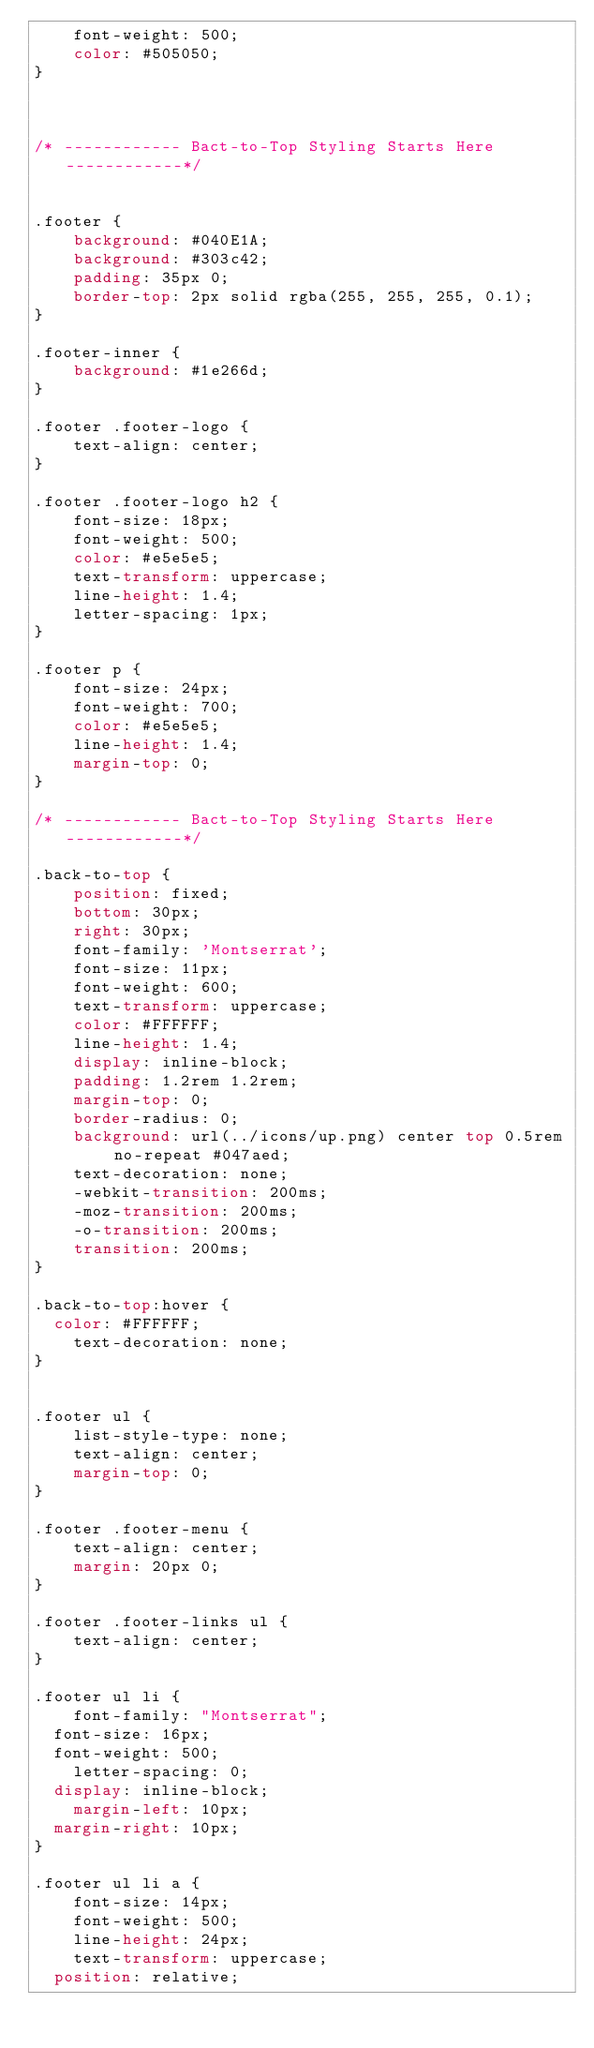<code> <loc_0><loc_0><loc_500><loc_500><_CSS_>	font-weight: 500;
	color: #505050;
}



/* ------------ Bact-to-Top Styling Starts Here ------------*/


.footer {
	background: #040E1A;
	background: #303c42;
	padding: 35px 0;
	border-top: 2px solid rgba(255, 255, 255, 0.1);
}

.footer-inner {
	background: #1e266d;
}

.footer .footer-logo {
	text-align: center;
}

.footer .footer-logo h2 {
	font-size: 18px;
	font-weight: 500;
	color: #e5e5e5;
	text-transform: uppercase;
	line-height: 1.4;
	letter-spacing: 1px;
}

.footer p {
	font-size: 24px;
	font-weight: 700;
	color: #e5e5e5;
	line-height: 1.4;
	margin-top: 0;
}

/* ------------ Bact-to-Top Styling Starts Here ------------*/

.back-to-top {
	position: fixed;
	bottom: 30px;
	right: 30px;
	font-family: 'Montserrat';
	font-size: 11px;
	font-weight: 600;
	text-transform: uppercase;
	color: #FFFFFF;
	line-height: 1.4;
	display: inline-block;
	padding: 1.2rem 1.2rem;
	margin-top: 0;
	border-radius: 0;
	background: url(../icons/up.png) center top 0.5rem no-repeat #047aed;
	text-decoration: none;
	-webkit-transition: 200ms;
	-moz-transition: 200ms;
	-o-transition: 200ms;
	transition: 200ms;
}

.back-to-top:hover {
  color: #FFFFFF;
	text-decoration: none;
}


.footer ul {
	list-style-type: none;
	text-align: center;
	margin-top: 0;
}

.footer .footer-menu {
	text-align: center;
	margin: 20px 0;
}

.footer .footer-links ul {
	text-align: center;
}

.footer ul li {
	font-family: "Montserrat";
  font-size: 16px;
  font-weight: 500;
	letter-spacing: 0;
  display: inline-block;
	margin-left: 10px;
  margin-right: 10px;
}

.footer ul li a {
	font-size: 14px;
	font-weight: 500;
	line-height: 24px;
	text-transform: uppercase;
  position: relative;</code> 